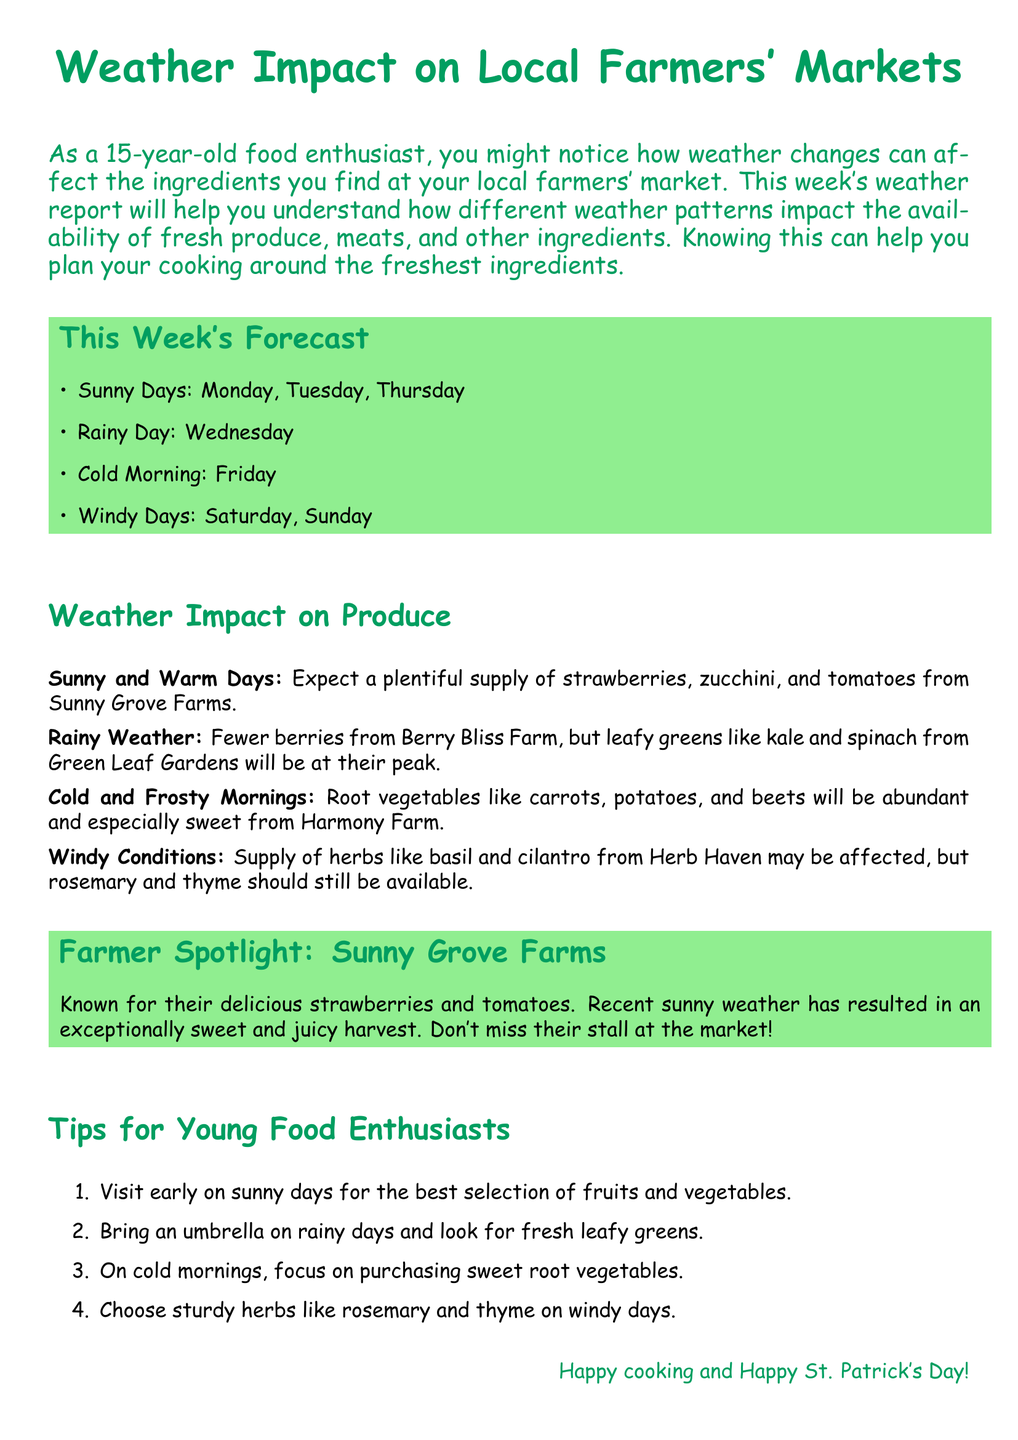What is the weather forecast for Wednesday? The document specifies that Wednesday will be a rainy day.
Answer: Rainy Day Which farm is known for strawberries and tomatoes? The document explicitly states that Sunny Grove Farms is known for their delicious strawberries and tomatoes.
Answer: Sunny Grove Farms What produce will be at its peak on rainy days? The report mentions that leafy greens like kale and spinach will be at their peak during rainy weather.
Answer: Leafy greens What type of vegetables will be abundant on cold mornings? The document indicates that root vegetables such as carrots, potatoes, and beets will be abundant and especially sweet on cold mornings.
Answer: Root vegetables How many sunny days are forecasted this week? The document lists three sunny days: Monday, Tuesday, and Thursday.
Answer: Three What should young food enthusiasts bring on rainy days? The report advises to bring an umbrella on rainy days.
Answer: Umbrella Which herbs may be affected by windy conditions? It mentions that the supply of herbs like basil and cilantro may be affected due to windiness.
Answer: Basil and cilantro What is one cooking tip mentioned for windy days? The document suggests choosing sturdy herbs like rosemary and thyme on windy days.
Answer: Rosemary and thyme 